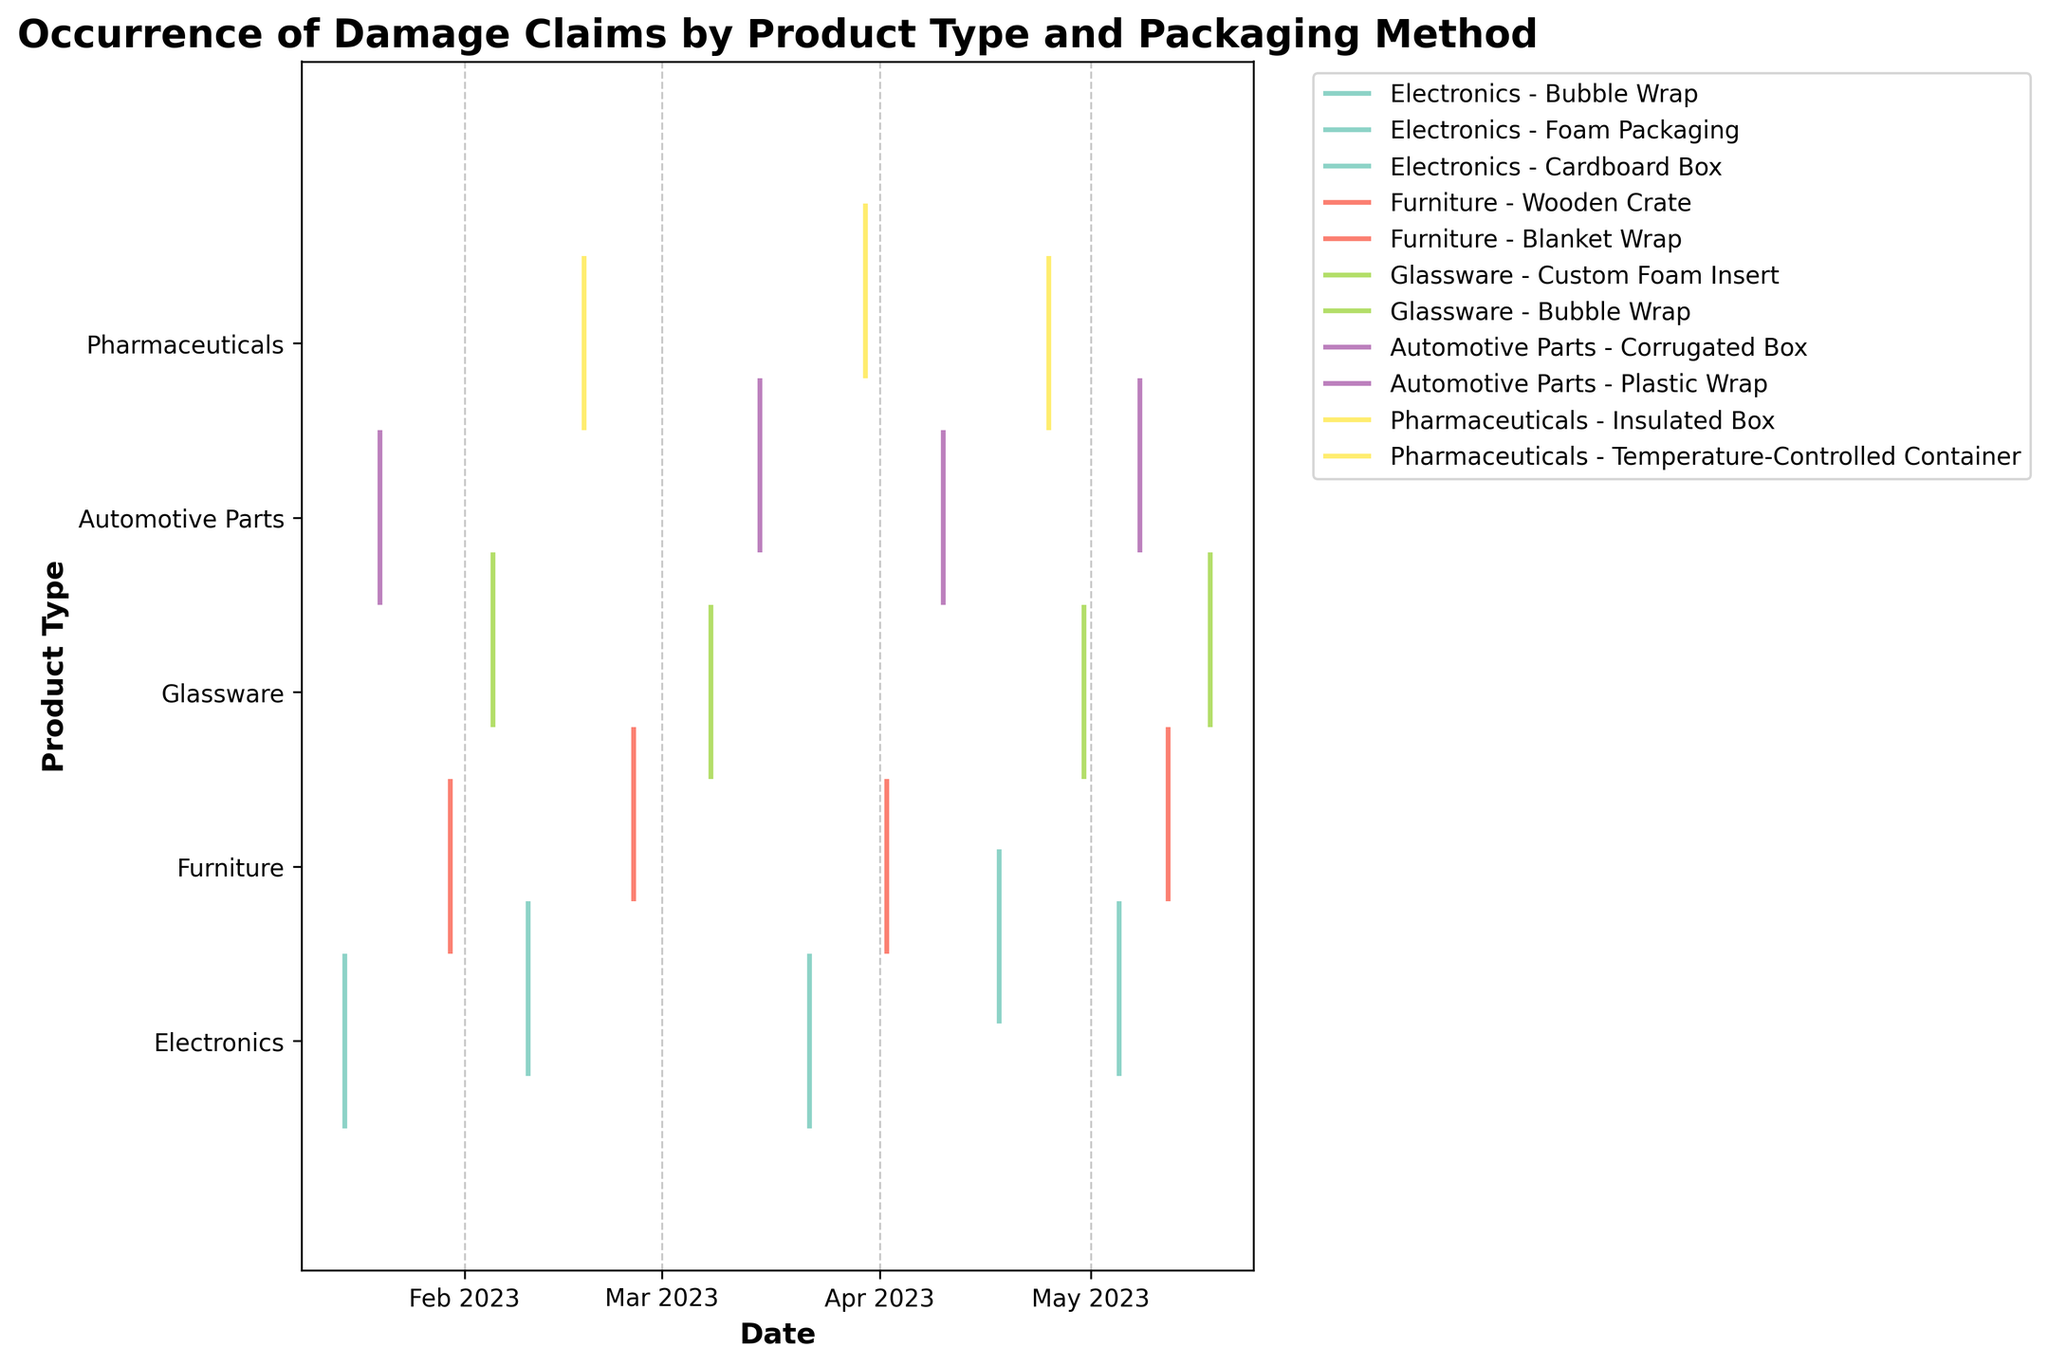What is the title of the plot? The title is usually located at the top of the plot and describes what the visual is representing. In this figure, the title is clearly displayed.
Answer: Occurrence of Damage Claims by Product Type and Packaging Method How many different product types are represented in the plot? The y-axis lists the different product types. By counting each unique label, we can determine the number of product types represented.
Answer: 5 Which packaging method for Glassware experienced the first damage claim of the year? By looking at the horizontal positions of the event lines for Glassware and identifying the earliest date, we can determine which method had the first claim.
Answer: Bubble Wrap What is the average number of damage claims per product type? First, count the total number of damage claims across all product types. Then, divide by the number of different product types to get the average.
Answer: 4 Which product type experienced the most damage claims overall? By counting the number of event lines for each product type along the y-axis, we can see which one has the most.
Answer: Electronics Are there any product types that had damage claims in every month between January and May? We need to check each product type to see if there is at least one damage claim in each month from January to May.
Answer: No For Electronics, which packaging method showed the highest number of damage claims? For the Electronics product type, we need to count the number of event lines for each packaging method and determine the one with the highest count.
Answer: Bubble Wrap Which month saw the highest number of damage claims for Automotive Parts? By focusing on the timeline section corresponding to Automotive Parts and counting the event lines for each month, we can identify the month with the highest number.
Answer: May Compare the damage claim patterns between Bubble Wrap for Electronics and Glassware. Which one had more consistent claims over the period? Examine the spacing and distribution of event lines over time for both, determining which has more evenly spaced claims.
Answer: Electronics What is the range of dates during which damage claims for Furniture using Wooden Crate were reported? Identify the first and last event lines for Wooden Crate under Furniture and determine the range between them.
Answer: January 30 to April 2 